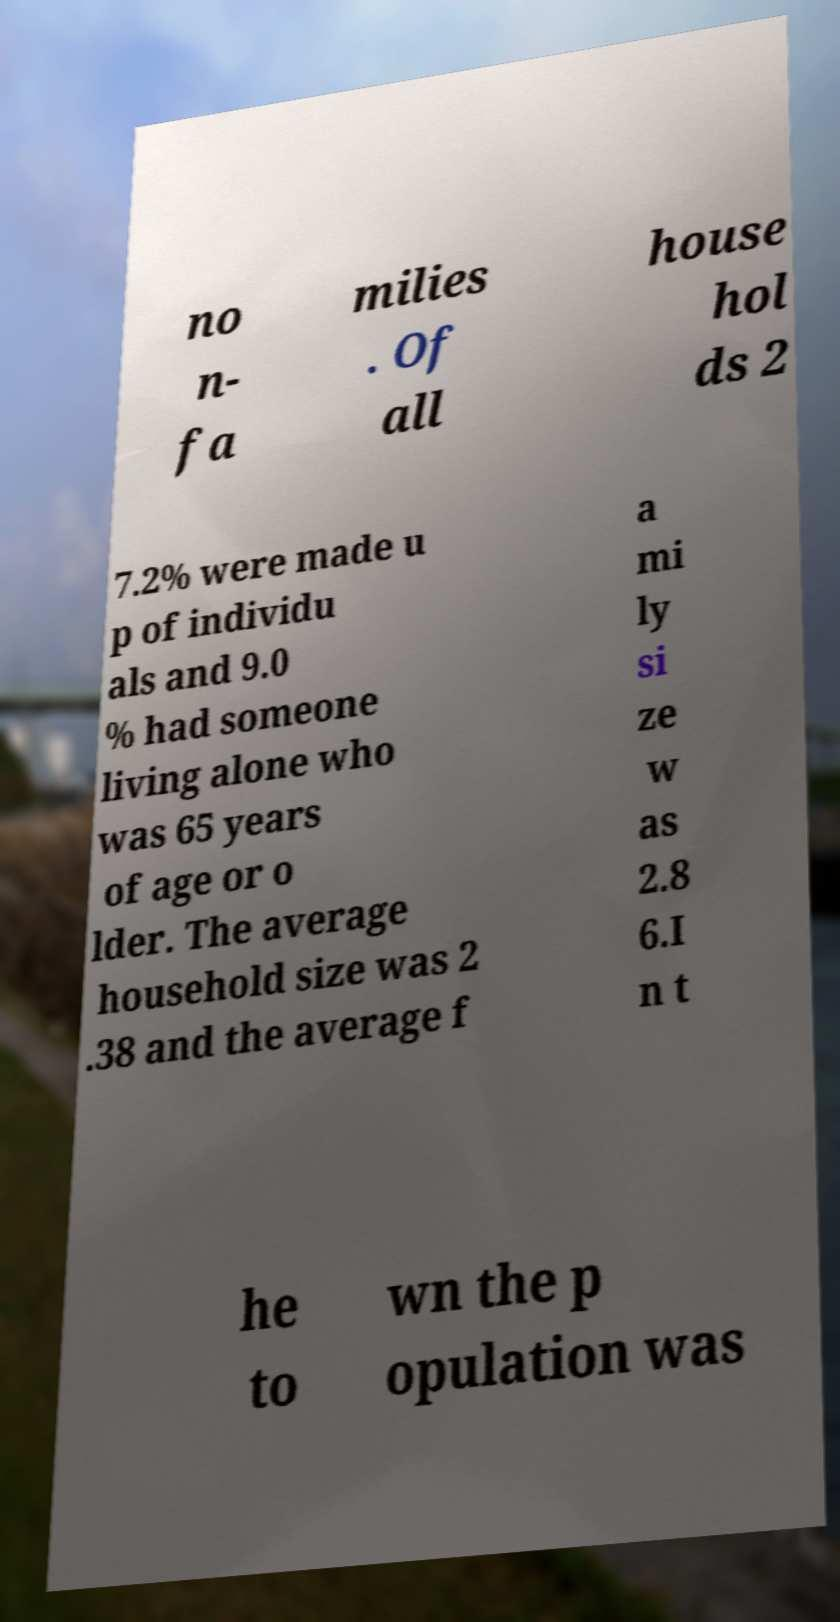Please identify and transcribe the text found in this image. no n- fa milies . Of all house hol ds 2 7.2% were made u p of individu als and 9.0 % had someone living alone who was 65 years of age or o lder. The average household size was 2 .38 and the average f a mi ly si ze w as 2.8 6.I n t he to wn the p opulation was 